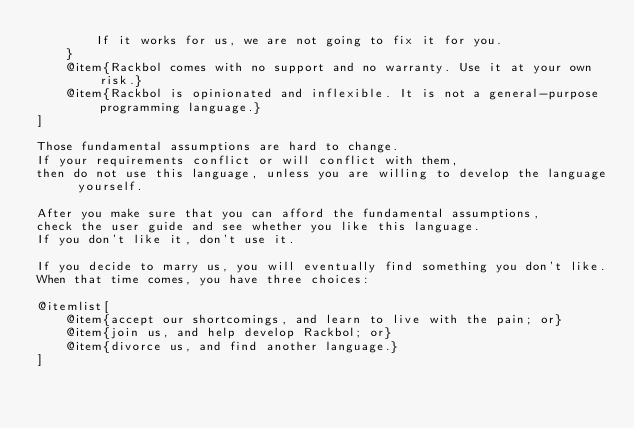Convert code to text. <code><loc_0><loc_0><loc_500><loc_500><_Racket_>        If it works for us, we are not going to fix it for you.
    }
    @item{Rackbol comes with no support and no warranty. Use it at your own risk.}
    @item{Rackbol is opinionated and inflexible. It is not a general-purpose programming language.}
]

Those fundamental assumptions are hard to change.
If your requirements conflict or will conflict with them,
then do not use this language, unless you are willing to develop the language yourself.

After you make sure that you can afford the fundamental assumptions,
check the user guide and see whether you like this language.
If you don't like it, don't use it.

If you decide to marry us, you will eventually find something you don't like.
When that time comes, you have three choices:

@itemlist[
    @item{accept our shortcomings, and learn to live with the pain; or}
    @item{join us, and help develop Rackbol; or}
    @item{divorce us, and find another language.}
]
</code> 